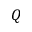Convert formula to latex. <formula><loc_0><loc_0><loc_500><loc_500>Q</formula> 